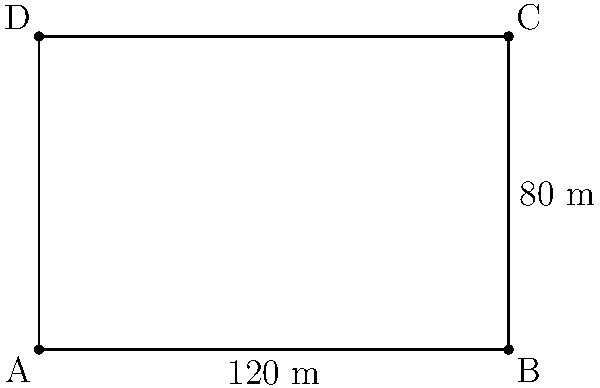As a seasoned football coach, you're tasked with calculating the area of a new training pitch. The pitch is rectangular, measuring 120 meters in length and 80 meters in width. What is the total area of this football pitch in square meters? To calculate the area of a rectangular football pitch, we need to multiply its length by its width. Let's break it down step-by-step:

1) The formula for the area of a rectangle is:
   $$ A = l \times w $$
   where $A$ is the area, $l$ is the length, and $w$ is the width.

2) We're given:
   - Length ($l$) = 120 meters
   - Width ($w$) = 80 meters

3) Let's substitute these values into our formula:
   $$ A = 120 \text{ m} \times 80 \text{ m} $$

4) Now, let's perform the multiplication:
   $$ A = 9,600 \text{ m}^2 $$

Therefore, the total area of the football pitch is 9,600 square meters.
Answer: 9,600 m² 